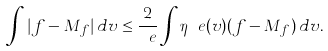<formula> <loc_0><loc_0><loc_500><loc_500>\int | f - M _ { f } | \, d v \leq \frac { 2 } { \ e } \int \eta _ { \ } e ( v ) ( f - M _ { f } ) \, d v .</formula> 